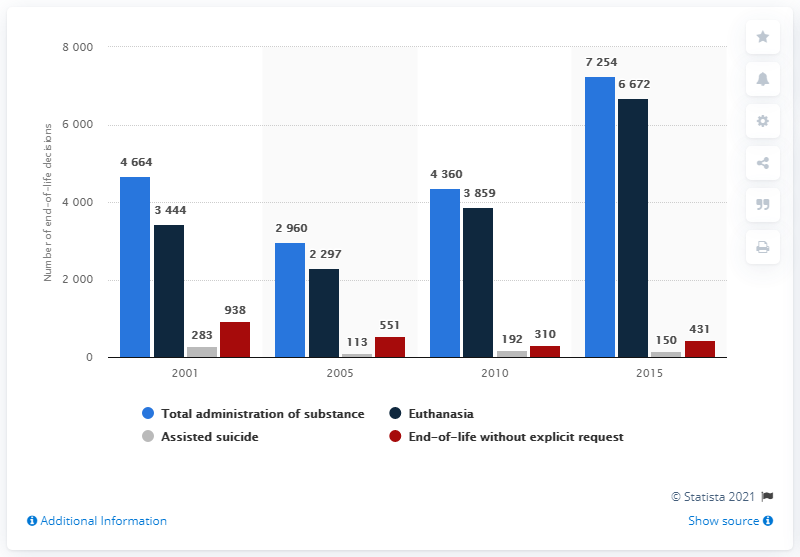List a handful of essential elements in this visual. In 2010, there were the fewest number of end-of-life decisions on average. 